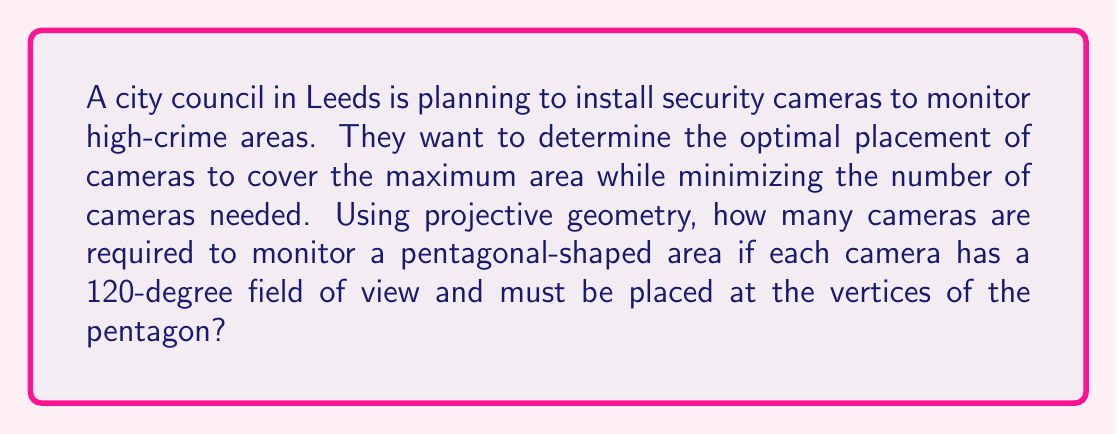Show me your answer to this math problem. To solve this problem, we'll use concepts from projective geometry:

1. In projective geometry, a pentagon can be represented as a set of 5 points in the projective plane.

2. Each camera's 120-degree field of view corresponds to a projective transformation that maps a sector of the projective plane to the camera's image plane.

3. To cover the entire pentagonal area, we need to ensure that every point within the pentagon is visible from at least one camera.

4. In projective geometry, three non-collinear points determine a unique projective transformation. This means that a 120-degree field of view can cover up to three consecutive vertices of the pentagon.

5. Let's number the vertices of the pentagon 1 through 5 in clockwise order.

6. A camera placed at vertex 1 with a 120-degree field of view can cover vertices 1, 2, and 3.

7. The next camera should be placed at vertex 4 to cover vertices 3, 4, and 5.

8. However, this leaves a gap between cameras 1 and 2, as vertex 5 is not covered by the first camera.

9. Therefore, we need a third camera at vertex 5 to ensure complete coverage.

10. The configuration can be represented mathematically as:

   $$C_1 = \{1, 2, 3\}$$
   $$C_2 = \{3, 4, 5\}$$
   $$C_3 = \{5, 1, 2\}$$

   Where $C_i$ represents the set of vertices covered by camera $i$.

11. This arrangement ensures that each vertex is covered by at least two cameras, providing redundancy and complete coverage of the pentagonal area.

Therefore, the optimal number of cameras required is 3.
Answer: 3 cameras 